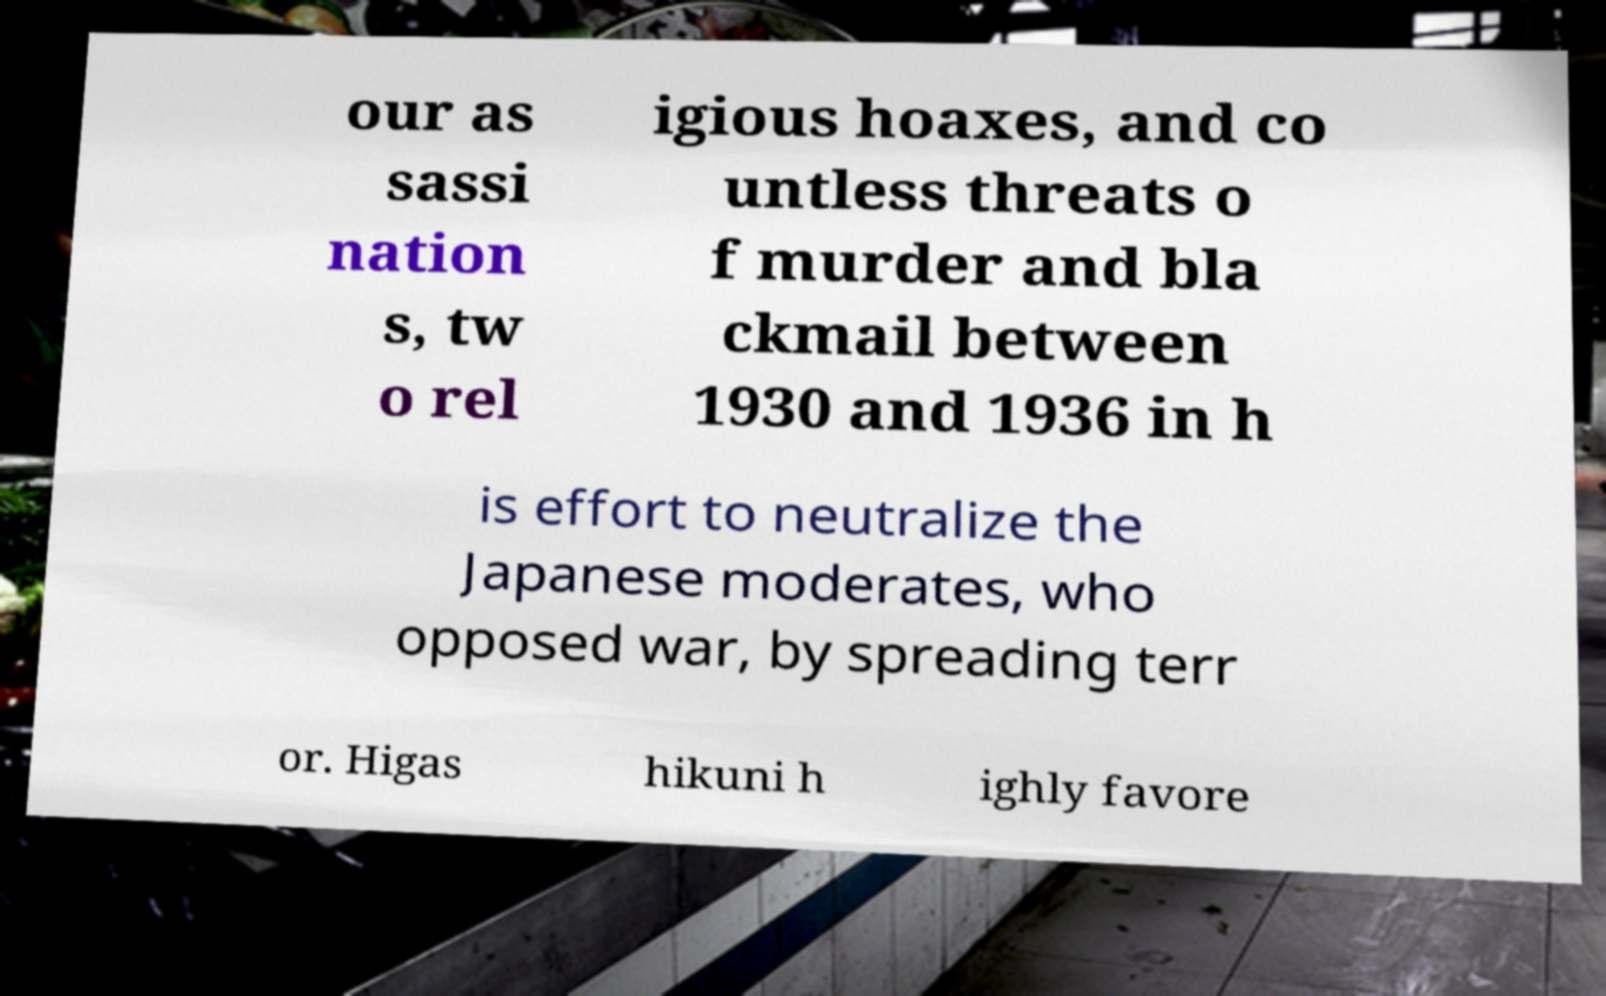Please read and relay the text visible in this image. What does it say? our as sassi nation s, tw o rel igious hoaxes, and co untless threats o f murder and bla ckmail between 1930 and 1936 in h is effort to neutralize the Japanese moderates, who opposed war, by spreading terr or. Higas hikuni h ighly favore 